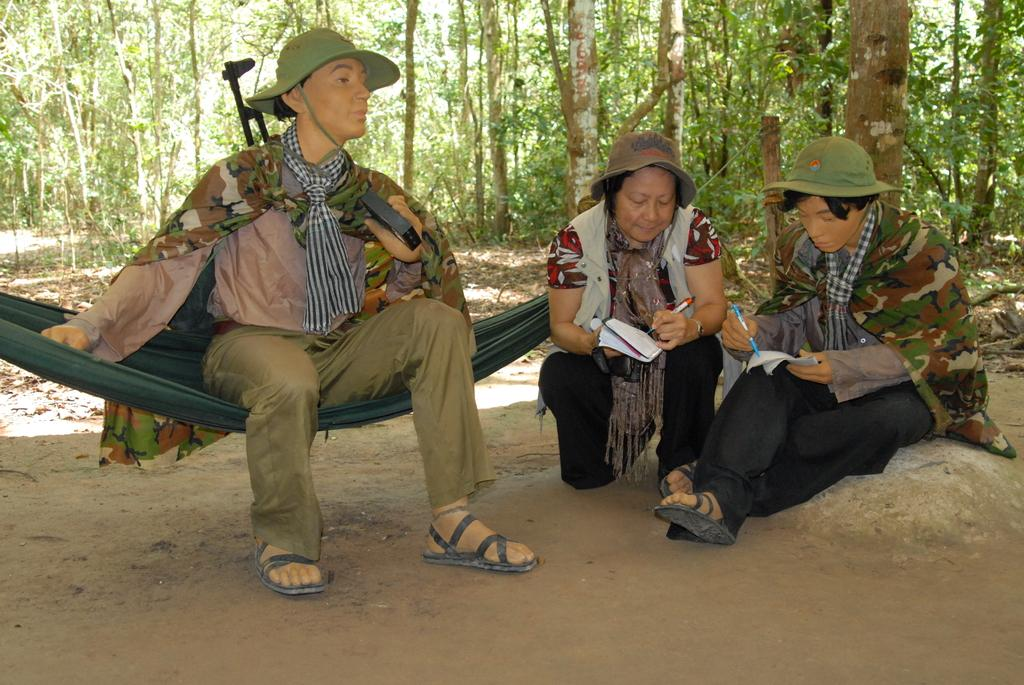What is the main subject in the image? There is a person's statue in the image. Can you describe the woman's position in the image? There is a woman sitting on the floor in the image. What else can be seen in the image besides the statue and the woman? There is another statue at the right side of the image. What can be seen in the background of the image? There are trees in the background of the image. What type of pies is the woman baking in the image? There is no indication of pies or baking in the image; the woman is sitting on the floor. 